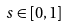Convert formula to latex. <formula><loc_0><loc_0><loc_500><loc_500>s \in [ 0 , 1 ]</formula> 